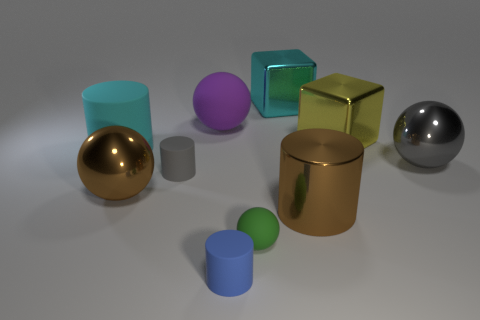What shape is the big metal object that is the same color as the large metallic cylinder?
Offer a terse response. Sphere. Are there any cyan blocks that have the same size as the yellow object?
Your answer should be very brief. Yes. Does the tiny blue object have the same shape as the gray object left of the gray metal ball?
Your response must be concise. Yes. What number of cylinders are gray things or gray rubber objects?
Offer a terse response. 1. The big metal cylinder is what color?
Provide a short and direct response. Brown. Is the number of small balls greater than the number of big purple metallic spheres?
Your answer should be compact. Yes. What number of objects are either brown metal objects on the left side of the green matte thing or large cyan objects?
Your answer should be compact. 3. Is the material of the cyan cube the same as the big purple sphere?
Your answer should be compact. No. What is the size of the brown metallic object that is the same shape as the blue object?
Make the answer very short. Large. Do the brown thing that is right of the blue rubber thing and the green matte thing that is on the left side of the large yellow thing have the same shape?
Your answer should be very brief. No. 